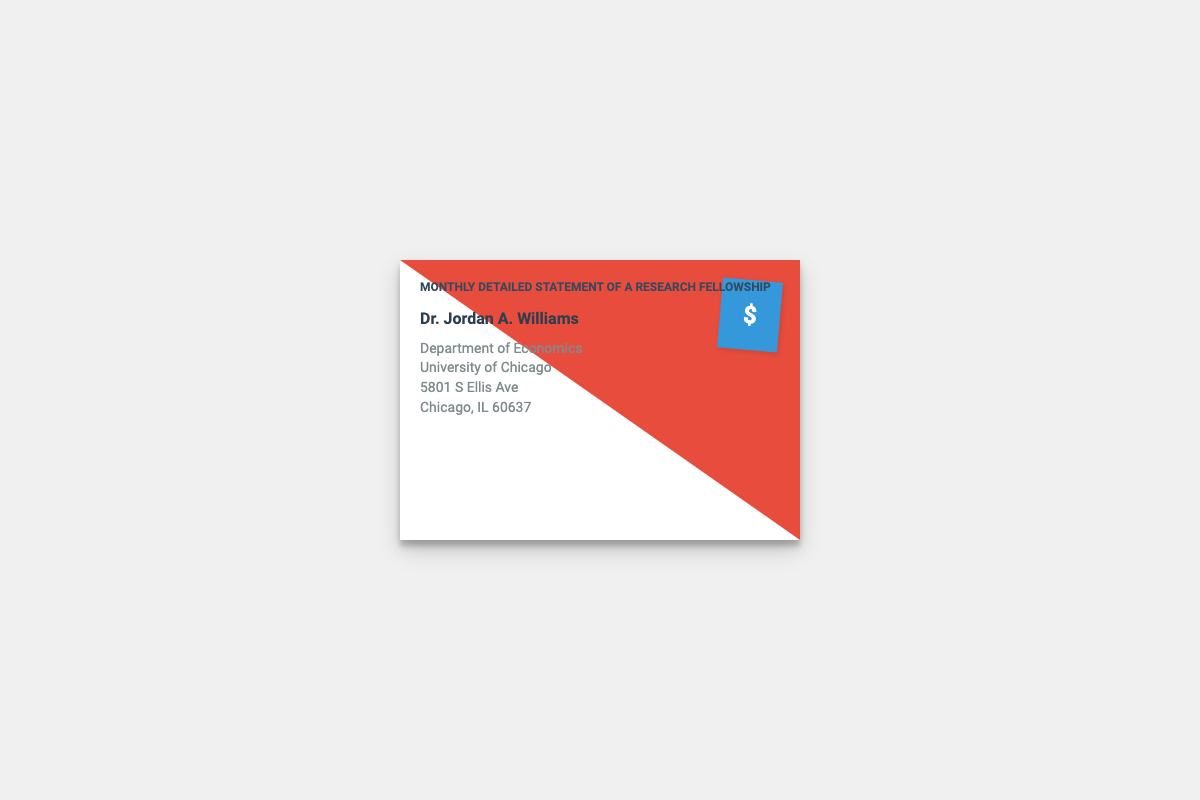What is the title of the document? The title is featured prominently at the top of the envelope, indicating the nature of the content.
Answer: Monthly Detailed Statement of a Research Fellowship Who is the recipient of this document? The name of the recipient is specified in the content section, identifying who the envelope is addressed to.
Answer: Dr. Jordan A. Williams What department is associated with the recipient? The document provides information about the recipient's department, which is an important detail for contextual identification.
Answer: Department of Economics What university is mentioned in the document? The name of the university is included as part of the address, relevant for understanding the academic context.
Answer: University of Chicago What city is the university located in? The city is specified in the address section of the document, providing geographical context.
Answer: Chicago What is the color of the stamp on the envelope? The stamp's color is part of the envelope's design, which can be visually noted.
Answer: Blue How is the stamp positioned on the envelope? The stamp's positioning is a design choice and can affect how the envelope is perceived visually.
Answer: Top right How many lines are in the recipient's address? The number of lines in the address is significant for understanding the formatting of the document.
Answer: Three What is the font style used in the header? The font style serves as an important aspect of the visual presentation of the document.
Answer: Roboto 